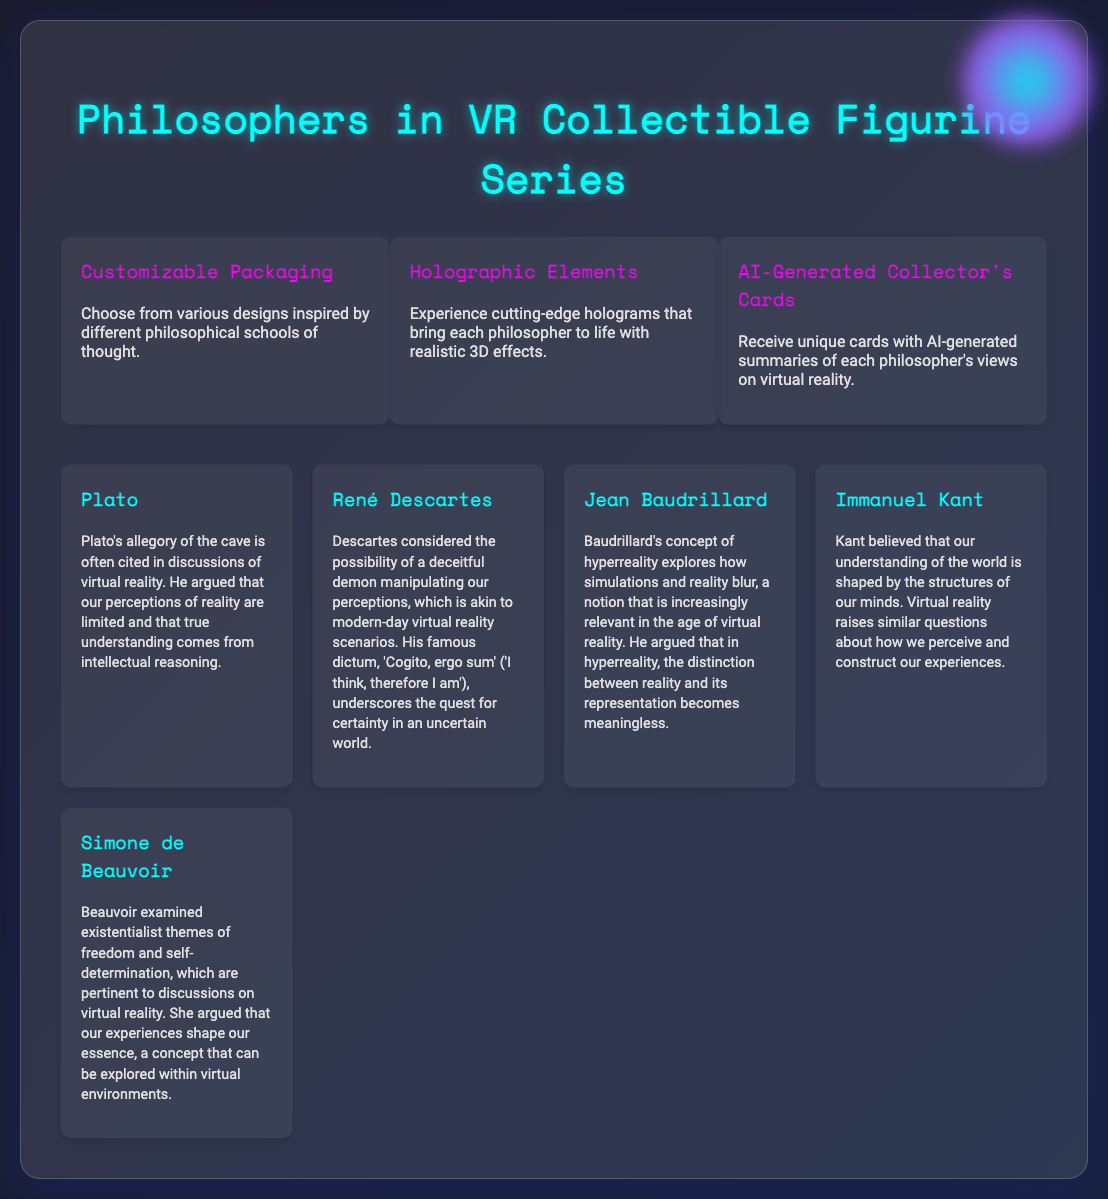What is the title of the collectible figurine series? The title of the series is prominently displayed at the top of the document.
Answer: Philosophers in VR Collectible Figurine Series How many features are highlighted in the document? The document lists and describes three key features of the packaging.
Answer: 3 Who is one of the philosophers mentioned in the series? The document provides a list of philosophers included in the series, showcasing their names.
Answer: Plato What unique feature of the collector's cards is mentioned? The document describes the cards as being generated by a specific technology that gives them uniqueness.
Answer: AI-generated What concept does Jean Baudrillard discuss in relation to virtual reality? The document summarizes Baudrillard's ideas as being tied to a specific philosophical term.
Answer: Hyperreality Which feature involves holograms? The document explicitly describes one of the three features dedicated to a specific technological aspect.
Answer: Holographic Elements What philosophical theme does Simone de Beauvoir's viewpoint relate to? The document connects Beauvoir’s examination to a broader existential concept relevant to virtual reality.
Answer: Freedom and self-determination Which philosopher is associated with the phrase "Cogito, ergo sum"? The document attributes this famous dictum to a specific philosopher, indicating his key ideas.
Answer: René Descartes What does the customizable packaging allow customers to do? The document details what customers can select concerning the packaging design.
Answer: Choose from various designs 